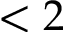<formula> <loc_0><loc_0><loc_500><loc_500>< 2</formula> 